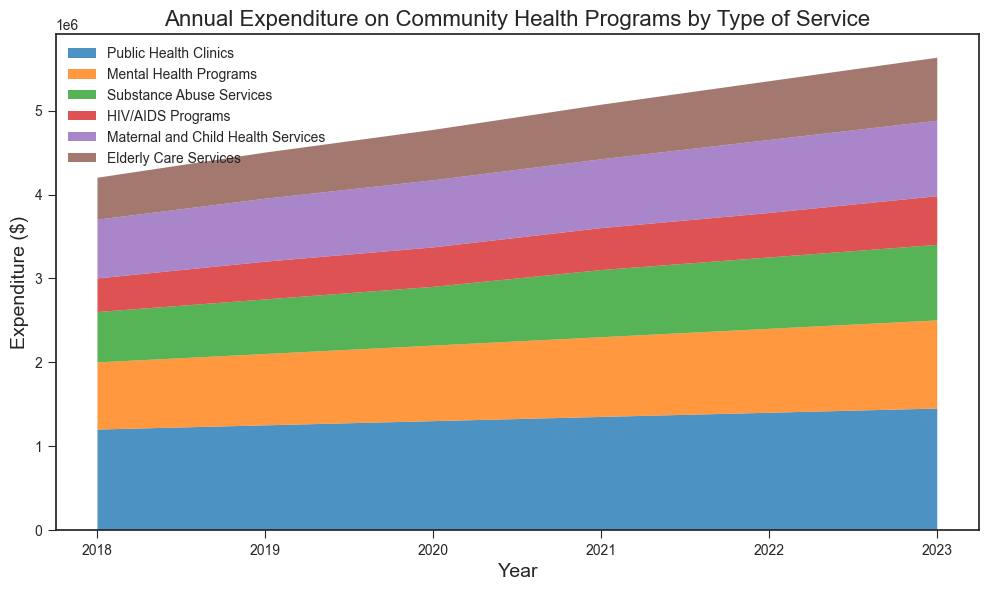What's the total expenditure on Public Health Clinics and Mental Health Programs in 2023? First, find the expenditure for Public Health Clinics in 2023, which is $1,450,000. Next, find the expenditure for Mental Health Programs in 2023, which is $1,050,000. Add these two values together: $1,450,000 + $1,050,000 = $2,500,000.
Answer: $2,500,000 Which year saw the largest increase in expenditure on HIV/AIDS Programs compared to the previous year? To determine the largest increase, calculate the difference in expenditure for HIV/AIDS Programs for each consecutive year:
2019 vs. 2018: $450,000 - $400,000 = $50,000
2020 vs. 2019: $470,000 - $450,000 = $20,000
2021 vs. 2020: $500,000 - $470,000 = $30,000
2022 vs. 2021: $530,000 - $500,000 = $30,000
2023 vs. 2022: $580,000 - $530,000 = $50,000
The largest increase happened in both 2019 and 2023, with an increase of $50,000.
Answer: 2019, 2023 Which service had the lowest expenditure in 2021, and what was the amount? Look at the expenditures for all services in 2021 and identify the lowest value: Public Health Clinics: $1,350,000, Mental Health Programs: $950,000, Substance Abuse Services: $800,000, HIV/AIDS Programs: $500,000, Maternal and Child Health Services: $820,000, Elderly Care Services: $650,000. HIV/AIDS Programs had the lowest expenditure at $500,000.
Answer: HIV/AIDS Programs, $500,000 How does the expenditure on Maternal and Child Health Services in 2020 compare to that in 2021? Compare the expenditure for Maternal and Child Health Services in 2020 ($800,000) to that in 2021 ($820,000). The expenditure increased from $800,000 to $820,000.
Answer: The expenditure increased What's the average annual expenditure on Elderly Care Services over the period from 2018 to 2023? Sum the expenditures for Elderly Care Services from 2018 to 2023 and divide by the number of years: ($500,000 + $550,000 + $600,000 + $650,000 + $700,000 + $750,000) / 6. The sum is $3,750,000, so the average is $3,750,000 / 6 = $625,000.
Answer: $625,000 